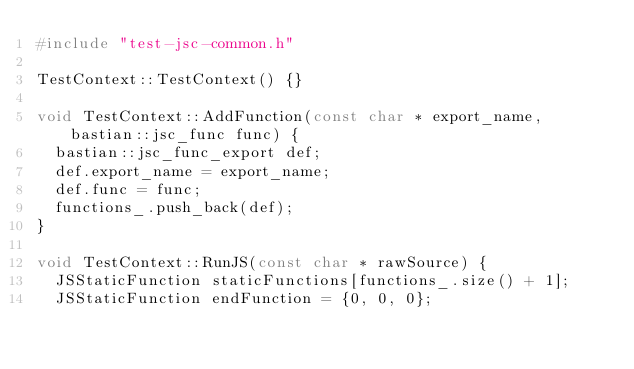<code> <loc_0><loc_0><loc_500><loc_500><_C++_>#include "test-jsc-common.h"

TestContext::TestContext() {}

void TestContext::AddFunction(const char * export_name, bastian::jsc_func func) {
  bastian::jsc_func_export def;
  def.export_name = export_name;
  def.func = func;
  functions_.push_back(def);
}

void TestContext::RunJS(const char * rawSource) {
  JSStaticFunction staticFunctions[functions_.size() + 1];
  JSStaticFunction endFunction = {0, 0, 0};
</code> 